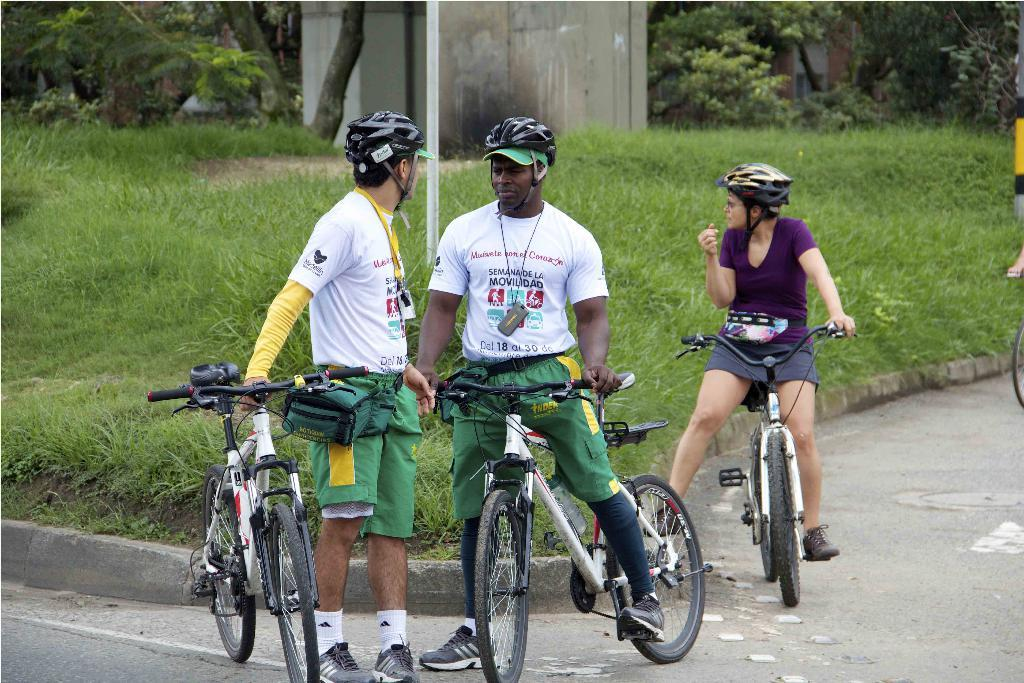How many people are in the image? There are three people in the image. What are the people doing in the image? All three people are riding bicycles. What safety precaution are the people taking while riding bicycles? The people are wearing helmets. Where does the scene take place? The scene takes place on a road. What can be seen in the background of the image? There is a pole, grass, and a wall in the background of the image. What type of nation is being cooked in the image? There is no nation being cooked in the image; it features three people riding bicycles on a road. What is the slope of the hill that the people are riding their bicycles on in the image? There is no hill or slope visible in the image; the scene takes place on a flat road. 